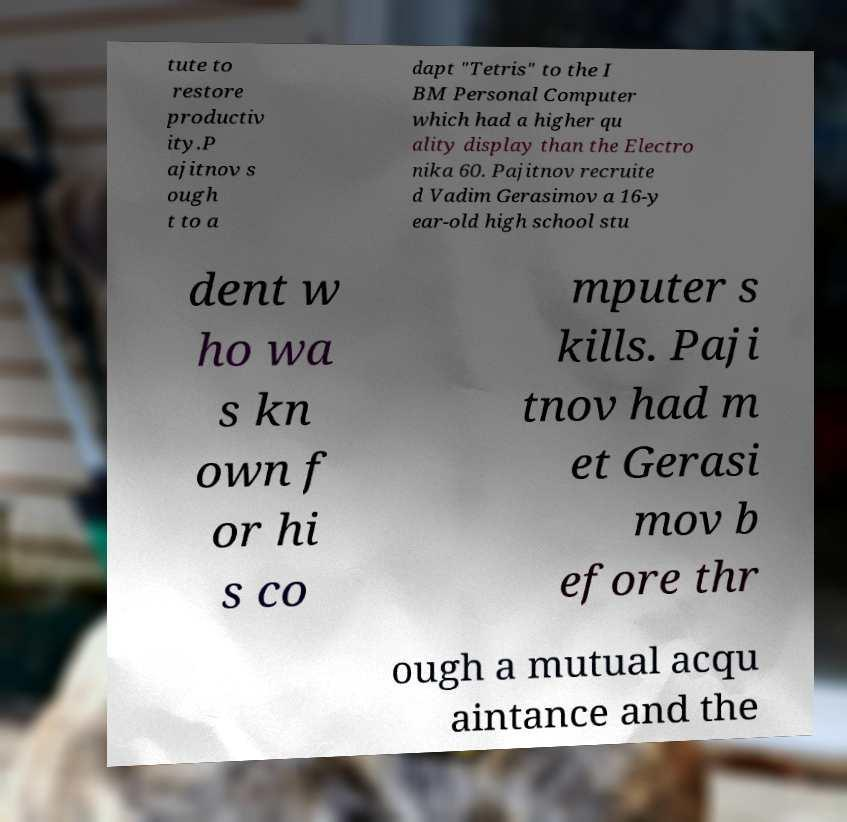Can you read and provide the text displayed in the image?This photo seems to have some interesting text. Can you extract and type it out for me? tute to restore productiv ity.P ajitnov s ough t to a dapt "Tetris" to the I BM Personal Computer which had a higher qu ality display than the Electro nika 60. Pajitnov recruite d Vadim Gerasimov a 16-y ear-old high school stu dent w ho wa s kn own f or hi s co mputer s kills. Paji tnov had m et Gerasi mov b efore thr ough a mutual acqu aintance and the 